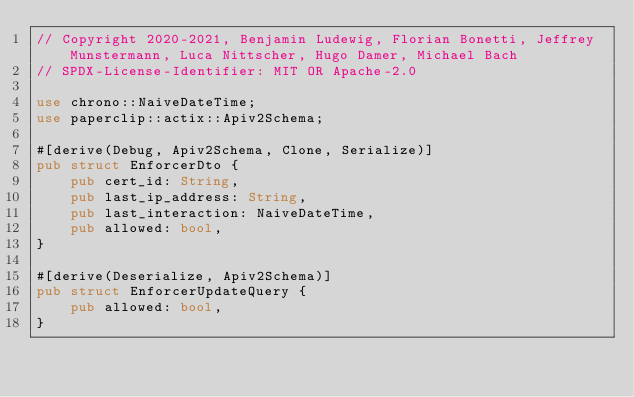<code> <loc_0><loc_0><loc_500><loc_500><_Rust_>// Copyright 2020-2021, Benjamin Ludewig, Florian Bonetti, Jeffrey Munstermann, Luca Nittscher, Hugo Damer, Michael Bach
// SPDX-License-Identifier: MIT OR Apache-2.0

use chrono::NaiveDateTime;
use paperclip::actix::Apiv2Schema;

#[derive(Debug, Apiv2Schema, Clone, Serialize)]
pub struct EnforcerDto {
    pub cert_id: String,
    pub last_ip_address: String,
    pub last_interaction: NaiveDateTime,
    pub allowed: bool,
}

#[derive(Deserialize, Apiv2Schema)]
pub struct EnforcerUpdateQuery {
    pub allowed: bool,
}
</code> 